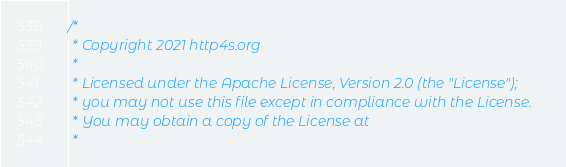<code> <loc_0><loc_0><loc_500><loc_500><_Scala_>/*
 * Copyright 2021 http4s.org
 *
 * Licensed under the Apache License, Version 2.0 (the "License");
 * you may not use this file except in compliance with the License.
 * You may obtain a copy of the License at
 *</code> 